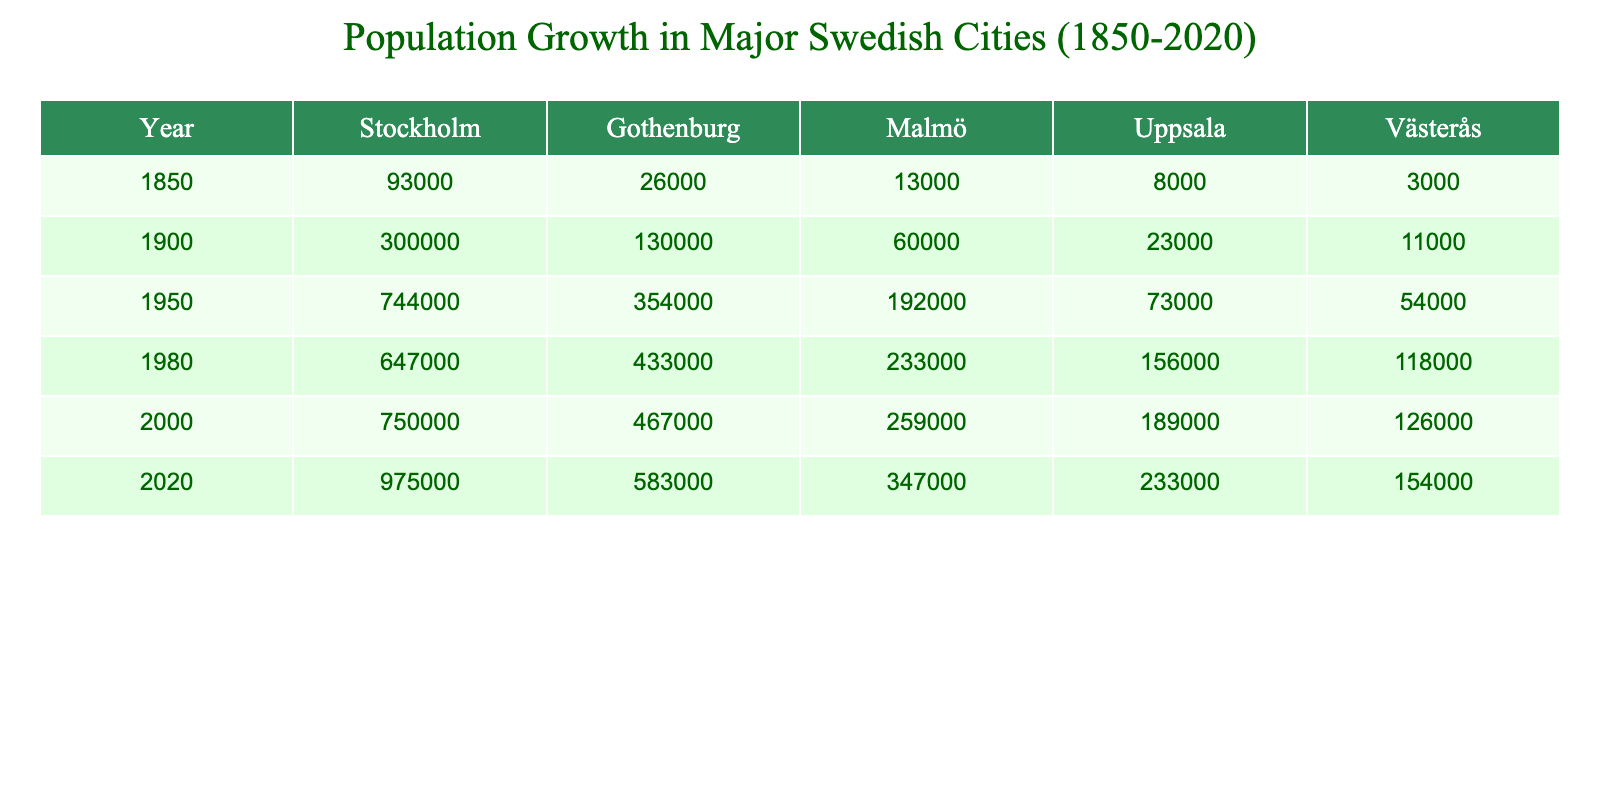What was the population of Stockholm in 1900? According to the table, the population of Stockholm in 1900 is listed as 300,000.
Answer: 300,000 Which city had a population of 13,000 in 1850? By examining the table, Malmö is shown to have a population of 13,000 in 1850.
Answer: Malmö What is the difference in population between Gothenburg in 1980 and 1950? The population of Gothenburg in 1980 is 433,000 and in 1950 it was 354,000. The difference is 433,000 - 354,000 = 79,000.
Answer: 79,000 Which city experienced the highest population growth from 1850 to 2020? To find the highest growth, we calculate the increase for each city: Stockholm (975,000 - 93,000 = 882,000), Gothenburg (583,000 - 26,000 = 557,000), Malmö (347,000 - 13,000 = 334,000), Uppsala (233,000 - 8,000 = 225,000), and Västerås (154,000 - 3,000 = 151,000). Stockholm had the highest growth of 882,000.
Answer: Stockholm What was the population of Malmö in 1950? The table indicates that the population of Malmö in 1950 is 192,000.
Answer: 192,000 What is the average population of Uppsala over the years recorded? The populations of Uppsala are 8,000 (1850), 23,000 (1900), 73,000 (1950), 156,000 (1980), 189,000 (2000), and 233,000 (2020). Summing these values gives 8,000 + 23,000 + 73,000 + 156,000 + 189,000 + 233,000 = 682,000. Dividing by 6 gives an average of 682,000 / 6 = 113,666.67, which rounds to 113,667.
Answer: 113,667 Did the population of Västerås increase from 1950 to 2020? Comparing the values, in 1950 the population was 54,000 and in 2020 it increased to 154,000. This confirms that it did increase.
Answer: Yes What was the overall population increase in Gothenburg from 2000 to 2020? Gothenburg had a population of 467,000 in 2000 and increased to 583,000 in 2020. The increase is 583,000 - 467,000 = 116,000.
Answer: 116,000 